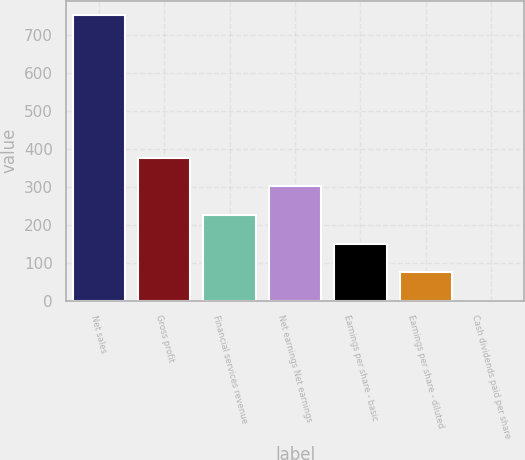<chart> <loc_0><loc_0><loc_500><loc_500><bar_chart><fcel>Net sales<fcel>Gross profit<fcel>Financial services revenue<fcel>Net earnings Net earnings<fcel>Earnings per share - basic<fcel>Earnings per share - diluted<fcel>Cash dividends paid per share<nl><fcel>753.2<fcel>376.78<fcel>226.22<fcel>301.5<fcel>150.94<fcel>75.66<fcel>0.38<nl></chart> 